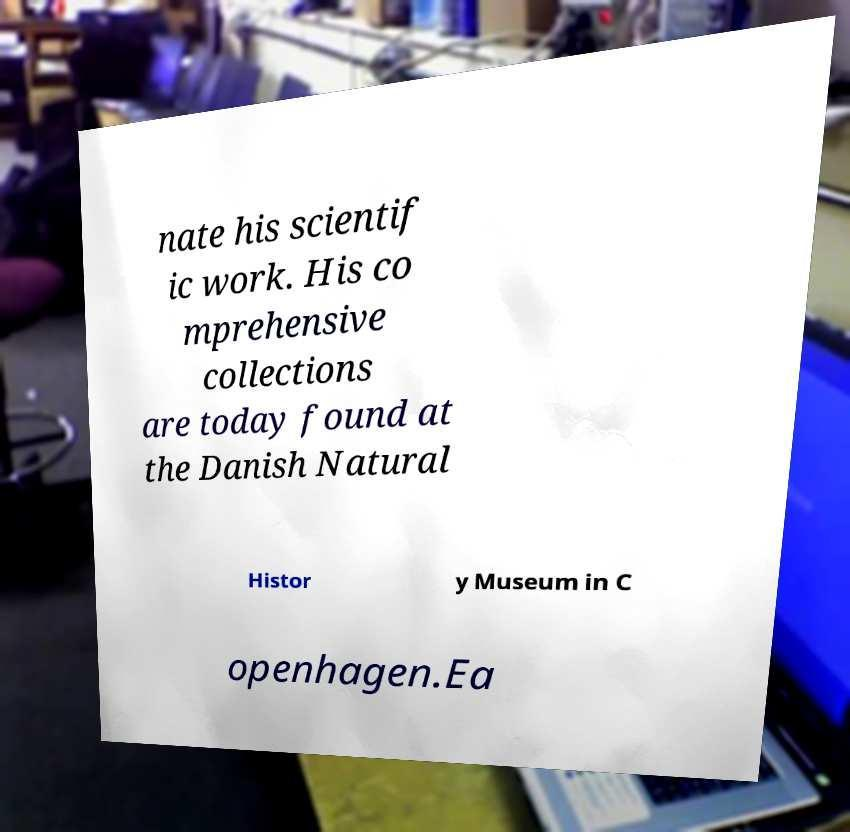Could you assist in decoding the text presented in this image and type it out clearly? nate his scientif ic work. His co mprehensive collections are today found at the Danish Natural Histor y Museum in C openhagen.Ea 